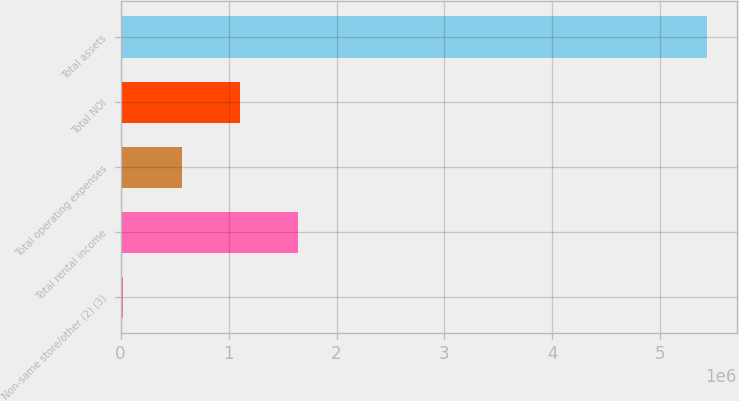<chart> <loc_0><loc_0><loc_500><loc_500><bar_chart><fcel>Non-same store/other (2) (3)<fcel>Total rental income<fcel>Total operating expenses<fcel>Total NOI<fcel>Total assets<nl><fcel>23195<fcel>1.64676e+06<fcel>564383<fcel>1.10557e+06<fcel>5.43507e+06<nl></chart> 